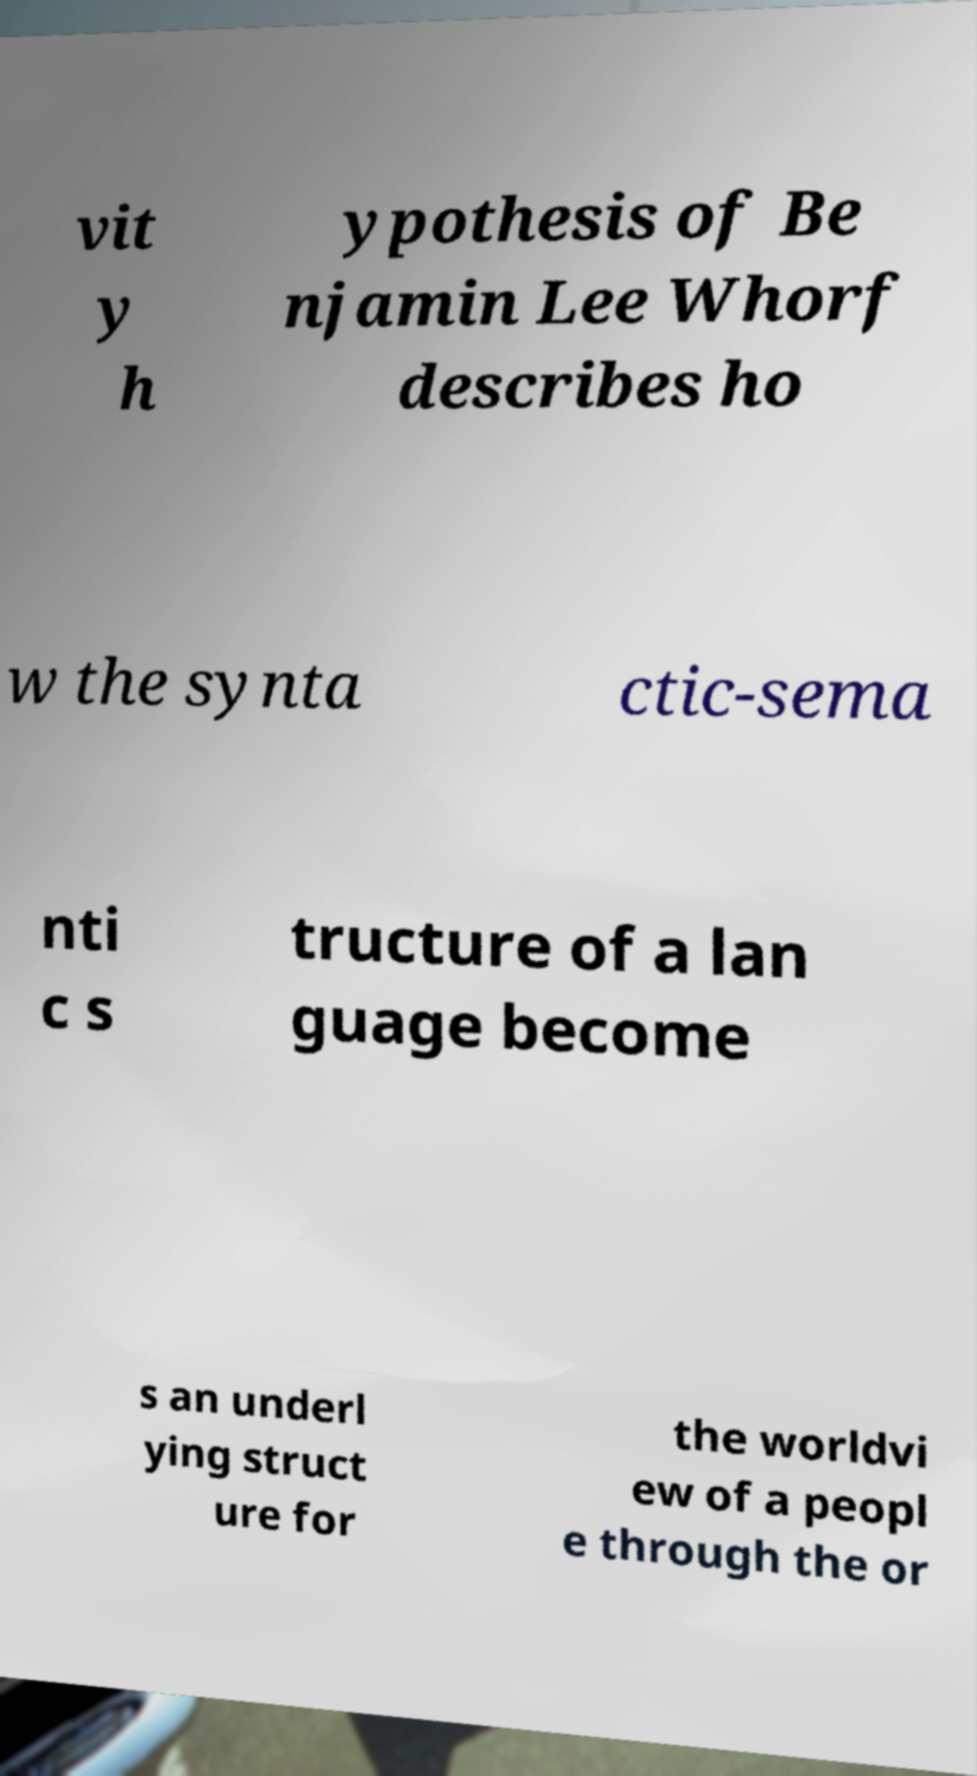I need the written content from this picture converted into text. Can you do that? vit y h ypothesis of Be njamin Lee Whorf describes ho w the synta ctic-sema nti c s tructure of a lan guage become s an underl ying struct ure for the worldvi ew of a peopl e through the or 